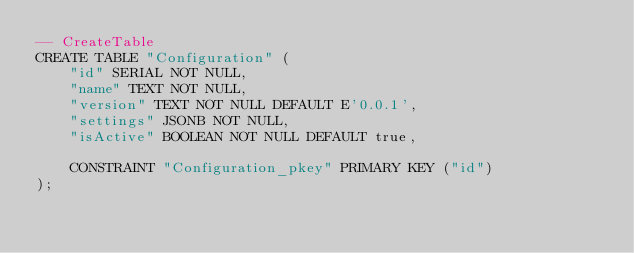<code> <loc_0><loc_0><loc_500><loc_500><_SQL_>-- CreateTable
CREATE TABLE "Configuration" (
    "id" SERIAL NOT NULL,
    "name" TEXT NOT NULL,
    "version" TEXT NOT NULL DEFAULT E'0.0.1',
    "settings" JSONB NOT NULL,
    "isActive" BOOLEAN NOT NULL DEFAULT true,

    CONSTRAINT "Configuration_pkey" PRIMARY KEY ("id")
);
</code> 